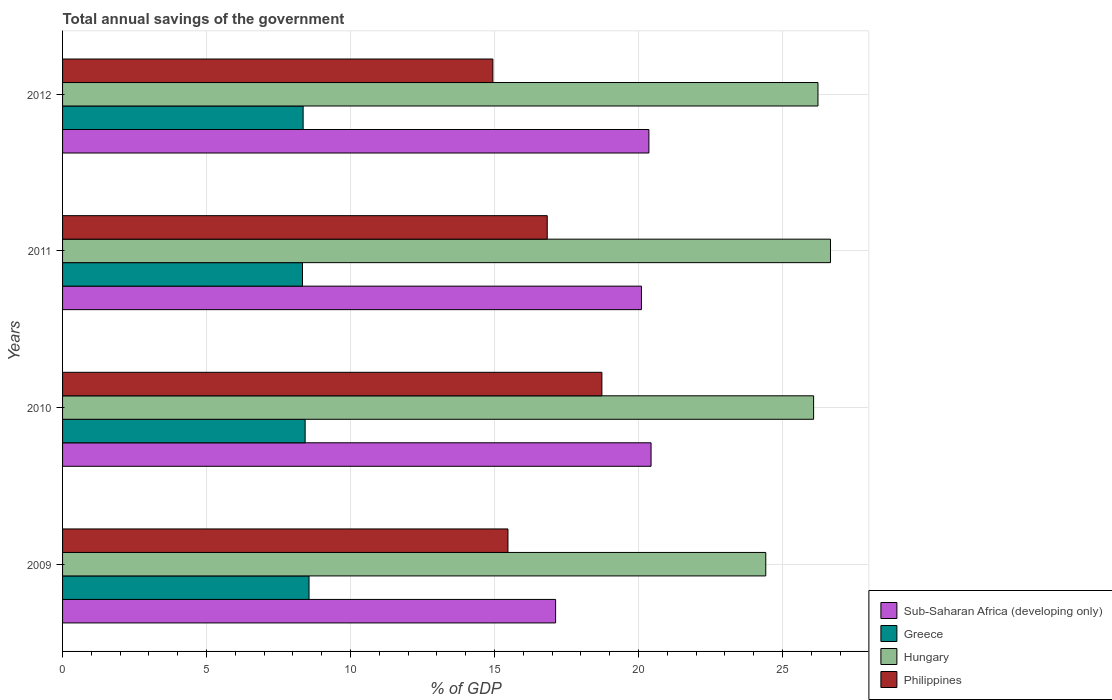How many different coloured bars are there?
Keep it short and to the point. 4. How many groups of bars are there?
Your answer should be very brief. 4. Are the number of bars per tick equal to the number of legend labels?
Offer a very short reply. Yes. How many bars are there on the 4th tick from the bottom?
Ensure brevity in your answer.  4. What is the label of the 3rd group of bars from the top?
Ensure brevity in your answer.  2010. What is the total annual savings of the government in Greece in 2010?
Make the answer very short. 8.42. Across all years, what is the maximum total annual savings of the government in Philippines?
Keep it short and to the point. 18.73. Across all years, what is the minimum total annual savings of the government in Philippines?
Your response must be concise. 14.94. In which year was the total annual savings of the government in Greece maximum?
Your answer should be compact. 2009. In which year was the total annual savings of the government in Hungary minimum?
Your response must be concise. 2009. What is the total total annual savings of the government in Sub-Saharan Africa (developing only) in the graph?
Your response must be concise. 78.02. What is the difference between the total annual savings of the government in Greece in 2011 and that in 2012?
Your answer should be compact. -0.02. What is the difference between the total annual savings of the government in Philippines in 2010 and the total annual savings of the government in Sub-Saharan Africa (developing only) in 2009?
Provide a succinct answer. 1.61. What is the average total annual savings of the government in Sub-Saharan Africa (developing only) per year?
Your answer should be very brief. 19.5. In the year 2009, what is the difference between the total annual savings of the government in Sub-Saharan Africa (developing only) and total annual savings of the government in Hungary?
Keep it short and to the point. -7.3. What is the ratio of the total annual savings of the government in Sub-Saharan Africa (developing only) in 2011 to that in 2012?
Provide a short and direct response. 0.99. Is the total annual savings of the government in Philippines in 2010 less than that in 2011?
Provide a short and direct response. No. What is the difference between the highest and the second highest total annual savings of the government in Sub-Saharan Africa (developing only)?
Keep it short and to the point. 0.07. What is the difference between the highest and the lowest total annual savings of the government in Philippines?
Give a very brief answer. 3.79. In how many years, is the total annual savings of the government in Greece greater than the average total annual savings of the government in Greece taken over all years?
Keep it short and to the point. 2. What does the 1st bar from the top in 2010 represents?
Provide a short and direct response. Philippines. What does the 3rd bar from the bottom in 2012 represents?
Make the answer very short. Hungary. Are all the bars in the graph horizontal?
Provide a short and direct response. Yes. How many years are there in the graph?
Offer a terse response. 4. Does the graph contain any zero values?
Make the answer very short. No. Where does the legend appear in the graph?
Your answer should be compact. Bottom right. How are the legend labels stacked?
Provide a succinct answer. Vertical. What is the title of the graph?
Offer a very short reply. Total annual savings of the government. What is the label or title of the X-axis?
Keep it short and to the point. % of GDP. What is the % of GDP of Sub-Saharan Africa (developing only) in 2009?
Your answer should be very brief. 17.12. What is the % of GDP of Greece in 2009?
Make the answer very short. 8.56. What is the % of GDP of Hungary in 2009?
Offer a very short reply. 24.42. What is the % of GDP of Philippines in 2009?
Ensure brevity in your answer.  15.47. What is the % of GDP in Sub-Saharan Africa (developing only) in 2010?
Your answer should be very brief. 20.44. What is the % of GDP in Greece in 2010?
Your answer should be very brief. 8.42. What is the % of GDP in Hungary in 2010?
Your answer should be very brief. 26.08. What is the % of GDP of Philippines in 2010?
Make the answer very short. 18.73. What is the % of GDP in Sub-Saharan Africa (developing only) in 2011?
Provide a short and direct response. 20.1. What is the % of GDP in Greece in 2011?
Your answer should be very brief. 8.33. What is the % of GDP of Hungary in 2011?
Your answer should be very brief. 26.67. What is the % of GDP of Philippines in 2011?
Make the answer very short. 16.83. What is the % of GDP of Sub-Saharan Africa (developing only) in 2012?
Give a very brief answer. 20.36. What is the % of GDP in Greece in 2012?
Provide a short and direct response. 8.35. What is the % of GDP of Hungary in 2012?
Ensure brevity in your answer.  26.23. What is the % of GDP of Philippines in 2012?
Your answer should be very brief. 14.94. Across all years, what is the maximum % of GDP in Sub-Saharan Africa (developing only)?
Ensure brevity in your answer.  20.44. Across all years, what is the maximum % of GDP in Greece?
Give a very brief answer. 8.56. Across all years, what is the maximum % of GDP of Hungary?
Your answer should be very brief. 26.67. Across all years, what is the maximum % of GDP in Philippines?
Offer a very short reply. 18.73. Across all years, what is the minimum % of GDP in Sub-Saharan Africa (developing only)?
Ensure brevity in your answer.  17.12. Across all years, what is the minimum % of GDP of Greece?
Offer a very short reply. 8.33. Across all years, what is the minimum % of GDP of Hungary?
Ensure brevity in your answer.  24.42. Across all years, what is the minimum % of GDP of Philippines?
Your response must be concise. 14.94. What is the total % of GDP in Sub-Saharan Africa (developing only) in the graph?
Offer a terse response. 78.02. What is the total % of GDP in Greece in the graph?
Provide a succinct answer. 33.67. What is the total % of GDP of Hungary in the graph?
Your answer should be very brief. 103.39. What is the total % of GDP in Philippines in the graph?
Make the answer very short. 65.97. What is the difference between the % of GDP of Sub-Saharan Africa (developing only) in 2009 and that in 2010?
Ensure brevity in your answer.  -3.31. What is the difference between the % of GDP in Greece in 2009 and that in 2010?
Make the answer very short. 0.13. What is the difference between the % of GDP in Hungary in 2009 and that in 2010?
Offer a very short reply. -1.66. What is the difference between the % of GDP of Philippines in 2009 and that in 2010?
Make the answer very short. -3.26. What is the difference between the % of GDP in Sub-Saharan Africa (developing only) in 2009 and that in 2011?
Provide a short and direct response. -2.98. What is the difference between the % of GDP of Greece in 2009 and that in 2011?
Provide a short and direct response. 0.23. What is the difference between the % of GDP in Hungary in 2009 and that in 2011?
Offer a terse response. -2.25. What is the difference between the % of GDP of Philippines in 2009 and that in 2011?
Your answer should be compact. -1.36. What is the difference between the % of GDP of Sub-Saharan Africa (developing only) in 2009 and that in 2012?
Make the answer very short. -3.24. What is the difference between the % of GDP of Greece in 2009 and that in 2012?
Keep it short and to the point. 0.2. What is the difference between the % of GDP of Hungary in 2009 and that in 2012?
Make the answer very short. -1.81. What is the difference between the % of GDP of Philippines in 2009 and that in 2012?
Provide a short and direct response. 0.52. What is the difference between the % of GDP of Sub-Saharan Africa (developing only) in 2010 and that in 2011?
Your answer should be compact. 0.33. What is the difference between the % of GDP of Greece in 2010 and that in 2011?
Give a very brief answer. 0.09. What is the difference between the % of GDP in Hungary in 2010 and that in 2011?
Your answer should be compact. -0.59. What is the difference between the % of GDP of Philippines in 2010 and that in 2011?
Provide a succinct answer. 1.9. What is the difference between the % of GDP of Sub-Saharan Africa (developing only) in 2010 and that in 2012?
Provide a succinct answer. 0.07. What is the difference between the % of GDP in Greece in 2010 and that in 2012?
Your answer should be compact. 0.07. What is the difference between the % of GDP in Hungary in 2010 and that in 2012?
Provide a short and direct response. -0.15. What is the difference between the % of GDP of Philippines in 2010 and that in 2012?
Ensure brevity in your answer.  3.79. What is the difference between the % of GDP in Sub-Saharan Africa (developing only) in 2011 and that in 2012?
Your response must be concise. -0.26. What is the difference between the % of GDP in Greece in 2011 and that in 2012?
Keep it short and to the point. -0.02. What is the difference between the % of GDP in Hungary in 2011 and that in 2012?
Provide a short and direct response. 0.43. What is the difference between the % of GDP of Philippines in 2011 and that in 2012?
Offer a very short reply. 1.89. What is the difference between the % of GDP in Sub-Saharan Africa (developing only) in 2009 and the % of GDP in Greece in 2010?
Your response must be concise. 8.7. What is the difference between the % of GDP of Sub-Saharan Africa (developing only) in 2009 and the % of GDP of Hungary in 2010?
Your answer should be very brief. -8.96. What is the difference between the % of GDP in Sub-Saharan Africa (developing only) in 2009 and the % of GDP in Philippines in 2010?
Offer a very short reply. -1.61. What is the difference between the % of GDP of Greece in 2009 and the % of GDP of Hungary in 2010?
Your response must be concise. -17.52. What is the difference between the % of GDP of Greece in 2009 and the % of GDP of Philippines in 2010?
Provide a succinct answer. -10.17. What is the difference between the % of GDP of Hungary in 2009 and the % of GDP of Philippines in 2010?
Provide a succinct answer. 5.69. What is the difference between the % of GDP of Sub-Saharan Africa (developing only) in 2009 and the % of GDP of Greece in 2011?
Keep it short and to the point. 8.79. What is the difference between the % of GDP in Sub-Saharan Africa (developing only) in 2009 and the % of GDP in Hungary in 2011?
Provide a succinct answer. -9.55. What is the difference between the % of GDP of Sub-Saharan Africa (developing only) in 2009 and the % of GDP of Philippines in 2011?
Your answer should be very brief. 0.29. What is the difference between the % of GDP of Greece in 2009 and the % of GDP of Hungary in 2011?
Your answer should be compact. -18.11. What is the difference between the % of GDP in Greece in 2009 and the % of GDP in Philippines in 2011?
Ensure brevity in your answer.  -8.27. What is the difference between the % of GDP in Hungary in 2009 and the % of GDP in Philippines in 2011?
Your answer should be compact. 7.59. What is the difference between the % of GDP of Sub-Saharan Africa (developing only) in 2009 and the % of GDP of Greece in 2012?
Your response must be concise. 8.77. What is the difference between the % of GDP in Sub-Saharan Africa (developing only) in 2009 and the % of GDP in Hungary in 2012?
Offer a terse response. -9.11. What is the difference between the % of GDP of Sub-Saharan Africa (developing only) in 2009 and the % of GDP of Philippines in 2012?
Offer a very short reply. 2.18. What is the difference between the % of GDP in Greece in 2009 and the % of GDP in Hungary in 2012?
Offer a terse response. -17.67. What is the difference between the % of GDP of Greece in 2009 and the % of GDP of Philippines in 2012?
Keep it short and to the point. -6.38. What is the difference between the % of GDP in Hungary in 2009 and the % of GDP in Philippines in 2012?
Your response must be concise. 9.48. What is the difference between the % of GDP in Sub-Saharan Africa (developing only) in 2010 and the % of GDP in Greece in 2011?
Provide a short and direct response. 12.1. What is the difference between the % of GDP of Sub-Saharan Africa (developing only) in 2010 and the % of GDP of Hungary in 2011?
Keep it short and to the point. -6.23. What is the difference between the % of GDP of Sub-Saharan Africa (developing only) in 2010 and the % of GDP of Philippines in 2011?
Provide a short and direct response. 3.61. What is the difference between the % of GDP in Greece in 2010 and the % of GDP in Hungary in 2011?
Give a very brief answer. -18.24. What is the difference between the % of GDP in Greece in 2010 and the % of GDP in Philippines in 2011?
Keep it short and to the point. -8.41. What is the difference between the % of GDP in Hungary in 2010 and the % of GDP in Philippines in 2011?
Offer a terse response. 9.25. What is the difference between the % of GDP in Sub-Saharan Africa (developing only) in 2010 and the % of GDP in Greece in 2012?
Your answer should be compact. 12.08. What is the difference between the % of GDP of Sub-Saharan Africa (developing only) in 2010 and the % of GDP of Hungary in 2012?
Your answer should be compact. -5.8. What is the difference between the % of GDP of Sub-Saharan Africa (developing only) in 2010 and the % of GDP of Philippines in 2012?
Your response must be concise. 5.49. What is the difference between the % of GDP of Greece in 2010 and the % of GDP of Hungary in 2012?
Your answer should be very brief. -17.81. What is the difference between the % of GDP in Greece in 2010 and the % of GDP in Philippines in 2012?
Provide a short and direct response. -6.52. What is the difference between the % of GDP of Hungary in 2010 and the % of GDP of Philippines in 2012?
Your response must be concise. 11.14. What is the difference between the % of GDP of Sub-Saharan Africa (developing only) in 2011 and the % of GDP of Greece in 2012?
Your response must be concise. 11.75. What is the difference between the % of GDP of Sub-Saharan Africa (developing only) in 2011 and the % of GDP of Hungary in 2012?
Offer a very short reply. -6.13. What is the difference between the % of GDP of Sub-Saharan Africa (developing only) in 2011 and the % of GDP of Philippines in 2012?
Offer a very short reply. 5.16. What is the difference between the % of GDP in Greece in 2011 and the % of GDP in Hungary in 2012?
Provide a short and direct response. -17.9. What is the difference between the % of GDP in Greece in 2011 and the % of GDP in Philippines in 2012?
Ensure brevity in your answer.  -6.61. What is the difference between the % of GDP of Hungary in 2011 and the % of GDP of Philippines in 2012?
Ensure brevity in your answer.  11.72. What is the average % of GDP in Sub-Saharan Africa (developing only) per year?
Your response must be concise. 19.5. What is the average % of GDP of Greece per year?
Provide a short and direct response. 8.42. What is the average % of GDP in Hungary per year?
Give a very brief answer. 25.85. What is the average % of GDP of Philippines per year?
Your answer should be very brief. 16.49. In the year 2009, what is the difference between the % of GDP of Sub-Saharan Africa (developing only) and % of GDP of Greece?
Make the answer very short. 8.56. In the year 2009, what is the difference between the % of GDP in Sub-Saharan Africa (developing only) and % of GDP in Hungary?
Your answer should be compact. -7.3. In the year 2009, what is the difference between the % of GDP of Sub-Saharan Africa (developing only) and % of GDP of Philippines?
Give a very brief answer. 1.65. In the year 2009, what is the difference between the % of GDP in Greece and % of GDP in Hungary?
Provide a short and direct response. -15.86. In the year 2009, what is the difference between the % of GDP of Greece and % of GDP of Philippines?
Offer a very short reply. -6.91. In the year 2009, what is the difference between the % of GDP of Hungary and % of GDP of Philippines?
Provide a short and direct response. 8.95. In the year 2010, what is the difference between the % of GDP in Sub-Saharan Africa (developing only) and % of GDP in Greece?
Give a very brief answer. 12.01. In the year 2010, what is the difference between the % of GDP of Sub-Saharan Africa (developing only) and % of GDP of Hungary?
Your answer should be very brief. -5.64. In the year 2010, what is the difference between the % of GDP in Sub-Saharan Africa (developing only) and % of GDP in Philippines?
Provide a succinct answer. 1.71. In the year 2010, what is the difference between the % of GDP in Greece and % of GDP in Hungary?
Your answer should be very brief. -17.66. In the year 2010, what is the difference between the % of GDP in Greece and % of GDP in Philippines?
Your answer should be very brief. -10.3. In the year 2010, what is the difference between the % of GDP in Hungary and % of GDP in Philippines?
Provide a succinct answer. 7.35. In the year 2011, what is the difference between the % of GDP of Sub-Saharan Africa (developing only) and % of GDP of Greece?
Provide a succinct answer. 11.77. In the year 2011, what is the difference between the % of GDP of Sub-Saharan Africa (developing only) and % of GDP of Hungary?
Keep it short and to the point. -6.56. In the year 2011, what is the difference between the % of GDP of Sub-Saharan Africa (developing only) and % of GDP of Philippines?
Make the answer very short. 3.27. In the year 2011, what is the difference between the % of GDP in Greece and % of GDP in Hungary?
Offer a very short reply. -18.33. In the year 2011, what is the difference between the % of GDP in Greece and % of GDP in Philippines?
Ensure brevity in your answer.  -8.5. In the year 2011, what is the difference between the % of GDP of Hungary and % of GDP of Philippines?
Your response must be concise. 9.84. In the year 2012, what is the difference between the % of GDP of Sub-Saharan Africa (developing only) and % of GDP of Greece?
Make the answer very short. 12.01. In the year 2012, what is the difference between the % of GDP in Sub-Saharan Africa (developing only) and % of GDP in Hungary?
Ensure brevity in your answer.  -5.87. In the year 2012, what is the difference between the % of GDP of Sub-Saharan Africa (developing only) and % of GDP of Philippines?
Ensure brevity in your answer.  5.42. In the year 2012, what is the difference between the % of GDP in Greece and % of GDP in Hungary?
Provide a short and direct response. -17.88. In the year 2012, what is the difference between the % of GDP of Greece and % of GDP of Philippines?
Give a very brief answer. -6.59. In the year 2012, what is the difference between the % of GDP of Hungary and % of GDP of Philippines?
Make the answer very short. 11.29. What is the ratio of the % of GDP of Sub-Saharan Africa (developing only) in 2009 to that in 2010?
Provide a succinct answer. 0.84. What is the ratio of the % of GDP of Greece in 2009 to that in 2010?
Your response must be concise. 1.02. What is the ratio of the % of GDP of Hungary in 2009 to that in 2010?
Keep it short and to the point. 0.94. What is the ratio of the % of GDP of Philippines in 2009 to that in 2010?
Ensure brevity in your answer.  0.83. What is the ratio of the % of GDP in Sub-Saharan Africa (developing only) in 2009 to that in 2011?
Offer a very short reply. 0.85. What is the ratio of the % of GDP of Greece in 2009 to that in 2011?
Your answer should be compact. 1.03. What is the ratio of the % of GDP in Hungary in 2009 to that in 2011?
Offer a very short reply. 0.92. What is the ratio of the % of GDP in Philippines in 2009 to that in 2011?
Provide a short and direct response. 0.92. What is the ratio of the % of GDP in Sub-Saharan Africa (developing only) in 2009 to that in 2012?
Offer a terse response. 0.84. What is the ratio of the % of GDP of Greece in 2009 to that in 2012?
Your response must be concise. 1.02. What is the ratio of the % of GDP of Hungary in 2009 to that in 2012?
Keep it short and to the point. 0.93. What is the ratio of the % of GDP in Philippines in 2009 to that in 2012?
Your answer should be compact. 1.03. What is the ratio of the % of GDP in Sub-Saharan Africa (developing only) in 2010 to that in 2011?
Ensure brevity in your answer.  1.02. What is the ratio of the % of GDP in Greece in 2010 to that in 2011?
Offer a very short reply. 1.01. What is the ratio of the % of GDP in Philippines in 2010 to that in 2011?
Your response must be concise. 1.11. What is the ratio of the % of GDP of Greece in 2010 to that in 2012?
Offer a terse response. 1.01. What is the ratio of the % of GDP of Hungary in 2010 to that in 2012?
Your answer should be very brief. 0.99. What is the ratio of the % of GDP in Philippines in 2010 to that in 2012?
Offer a very short reply. 1.25. What is the ratio of the % of GDP in Sub-Saharan Africa (developing only) in 2011 to that in 2012?
Offer a very short reply. 0.99. What is the ratio of the % of GDP in Hungary in 2011 to that in 2012?
Ensure brevity in your answer.  1.02. What is the ratio of the % of GDP of Philippines in 2011 to that in 2012?
Give a very brief answer. 1.13. What is the difference between the highest and the second highest % of GDP in Sub-Saharan Africa (developing only)?
Offer a terse response. 0.07. What is the difference between the highest and the second highest % of GDP in Greece?
Provide a short and direct response. 0.13. What is the difference between the highest and the second highest % of GDP of Hungary?
Your answer should be very brief. 0.43. What is the difference between the highest and the second highest % of GDP in Philippines?
Make the answer very short. 1.9. What is the difference between the highest and the lowest % of GDP in Sub-Saharan Africa (developing only)?
Ensure brevity in your answer.  3.31. What is the difference between the highest and the lowest % of GDP of Greece?
Provide a short and direct response. 0.23. What is the difference between the highest and the lowest % of GDP of Hungary?
Your answer should be compact. 2.25. What is the difference between the highest and the lowest % of GDP of Philippines?
Offer a very short reply. 3.79. 